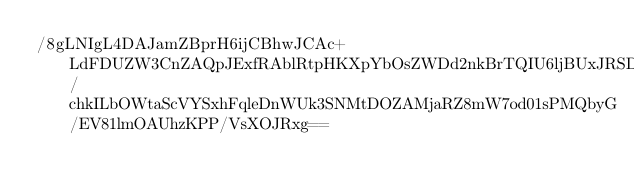<code> <loc_0><loc_0><loc_500><loc_500><_SML_>/8gLNIgL4DAJamZBprH6ijCBhwJCAc+LdFDUZW3CnZAQpJExfRAblRtpHKXpYbOsZWDd2nkBrTQIU6ljBUxJRSD6rMm9uiDLMPVc3I7GdW17bgfzG14qAkElpZcBMk/chkILbOWtaScVYSxhFqleDnWUk3SNMtDOZAMjaRZ8mW7od01sPMQbyG/EV81lmOAUhzKPP/VsXOJRxg==</code> 